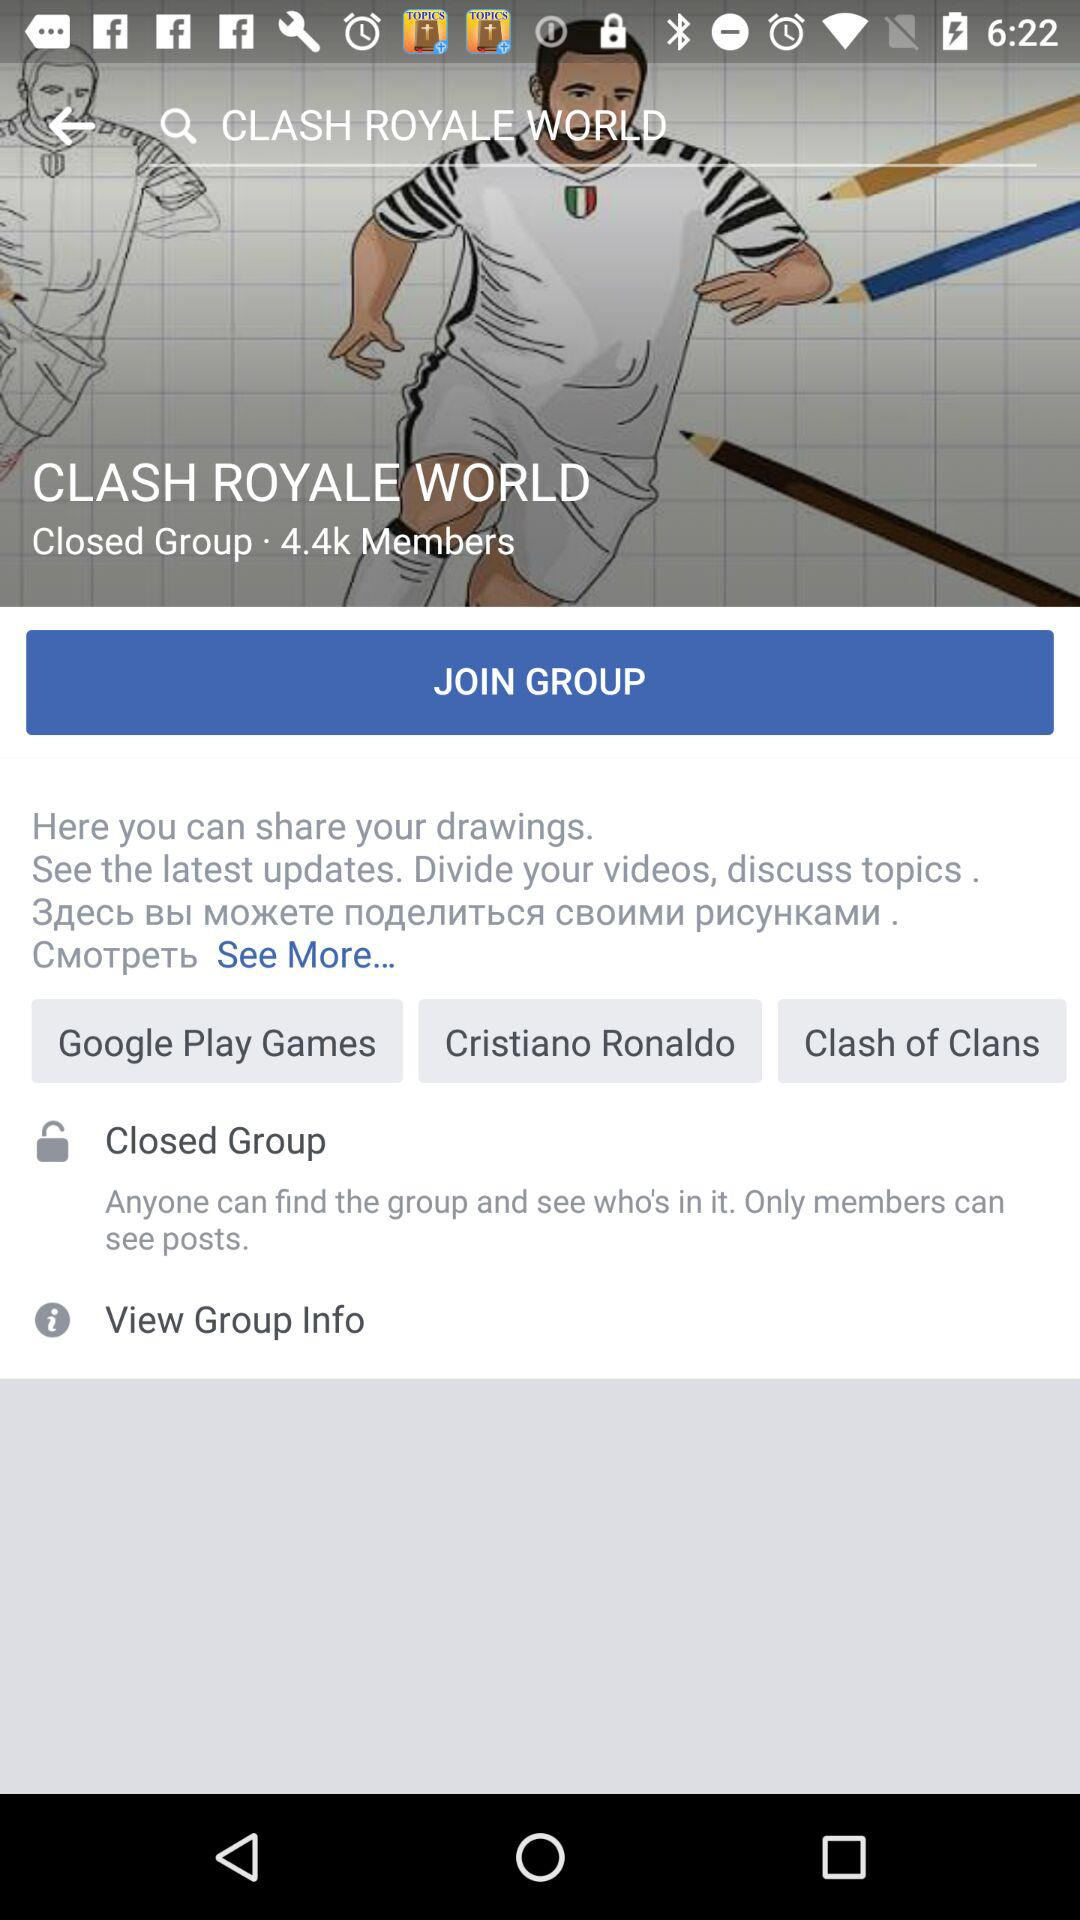How many members are there in the group? There are 4.4k members in the group. 